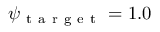Convert formula to latex. <formula><loc_0><loc_0><loc_500><loc_500>\psi _ { t a r g e t } = 1 . 0</formula> 